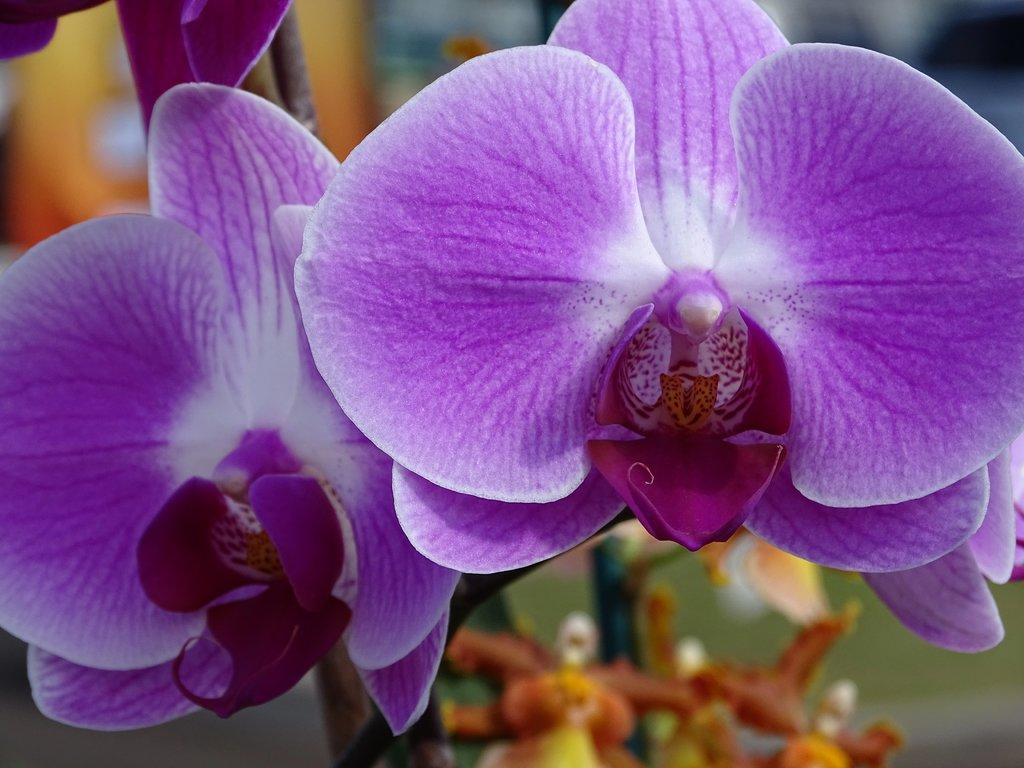What type of living organisms can be seen in the image? There are flowers in the image. What colors are the flowers in the image? The flowers are in white and purple color. Can you describe the background of the image? The background of the image is blurred. How many wrens can be seen in the image? There are no wrens present in the image; it features flowers. 